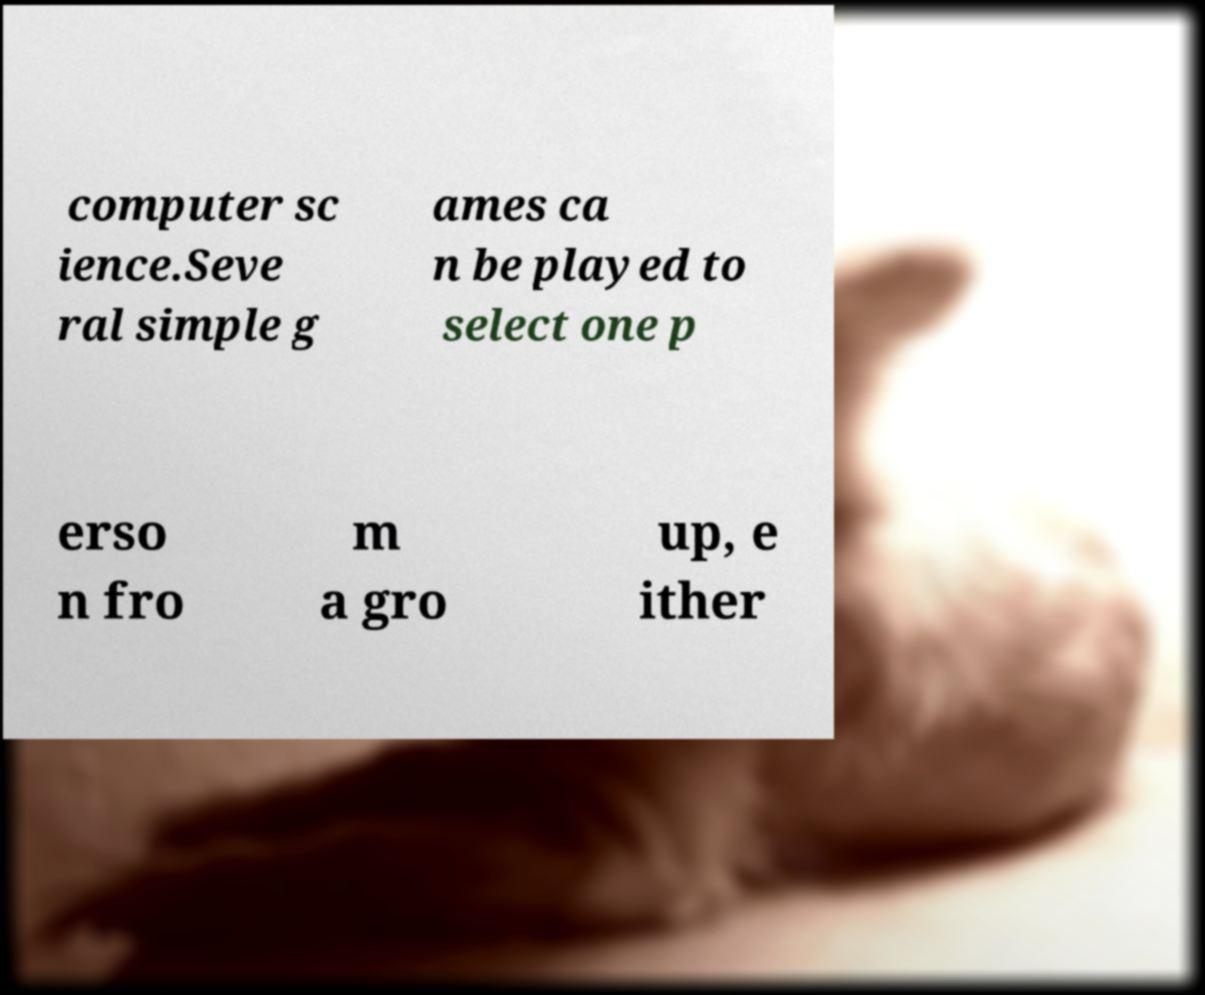Can you read and provide the text displayed in the image?This photo seems to have some interesting text. Can you extract and type it out for me? computer sc ience.Seve ral simple g ames ca n be played to select one p erso n fro m a gro up, e ither 